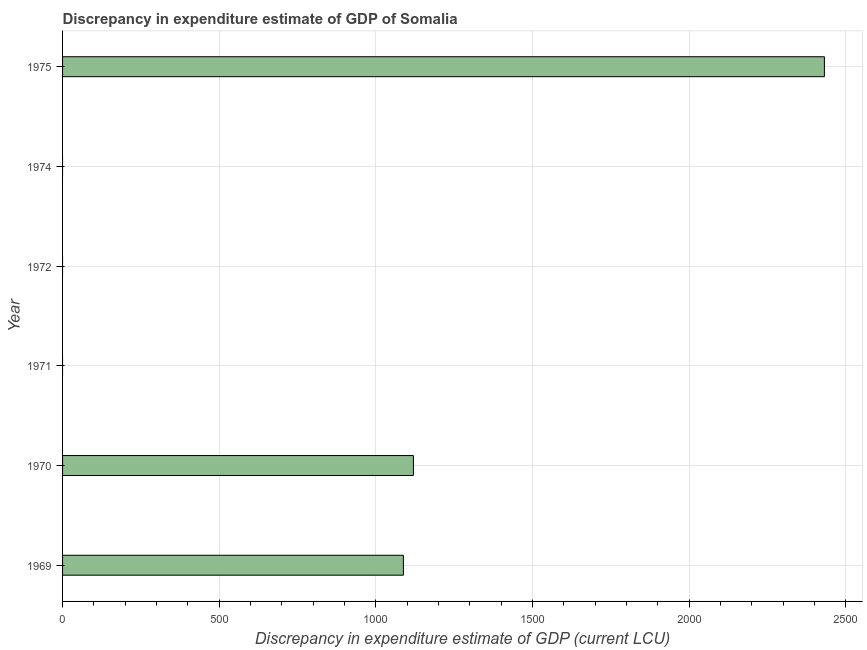What is the title of the graph?
Offer a terse response. Discrepancy in expenditure estimate of GDP of Somalia. What is the label or title of the X-axis?
Offer a terse response. Discrepancy in expenditure estimate of GDP (current LCU). What is the label or title of the Y-axis?
Offer a very short reply. Year. What is the discrepancy in expenditure estimate of gdp in 1971?
Your answer should be compact. 0. Across all years, what is the maximum discrepancy in expenditure estimate of gdp?
Your response must be concise. 2432. Across all years, what is the minimum discrepancy in expenditure estimate of gdp?
Offer a terse response. 0. In which year was the discrepancy in expenditure estimate of gdp maximum?
Make the answer very short. 1975. What is the sum of the discrepancy in expenditure estimate of gdp?
Your answer should be compact. 4640. What is the difference between the discrepancy in expenditure estimate of gdp in 1970 and 1975?
Provide a succinct answer. -1312. What is the average discrepancy in expenditure estimate of gdp per year?
Offer a terse response. 773. What is the median discrepancy in expenditure estimate of gdp?
Your answer should be very brief. 544. Is the discrepancy in expenditure estimate of gdp in 1970 less than that in 1975?
Provide a succinct answer. Yes. Is the difference between the discrepancy in expenditure estimate of gdp in 1970 and 1975 greater than the difference between any two years?
Make the answer very short. No. What is the difference between the highest and the second highest discrepancy in expenditure estimate of gdp?
Offer a terse response. 1312. What is the difference between the highest and the lowest discrepancy in expenditure estimate of gdp?
Give a very brief answer. 2432. In how many years, is the discrepancy in expenditure estimate of gdp greater than the average discrepancy in expenditure estimate of gdp taken over all years?
Offer a very short reply. 3. How many years are there in the graph?
Your answer should be very brief. 6. What is the difference between two consecutive major ticks on the X-axis?
Provide a short and direct response. 500. What is the Discrepancy in expenditure estimate of GDP (current LCU) in 1969?
Keep it short and to the point. 1088. What is the Discrepancy in expenditure estimate of GDP (current LCU) in 1970?
Make the answer very short. 1120. What is the Discrepancy in expenditure estimate of GDP (current LCU) of 1972?
Your answer should be very brief. 0. What is the Discrepancy in expenditure estimate of GDP (current LCU) in 1975?
Make the answer very short. 2432. What is the difference between the Discrepancy in expenditure estimate of GDP (current LCU) in 1969 and 1970?
Give a very brief answer. -32. What is the difference between the Discrepancy in expenditure estimate of GDP (current LCU) in 1969 and 1975?
Offer a terse response. -1344. What is the difference between the Discrepancy in expenditure estimate of GDP (current LCU) in 1970 and 1975?
Provide a succinct answer. -1312. What is the ratio of the Discrepancy in expenditure estimate of GDP (current LCU) in 1969 to that in 1975?
Provide a short and direct response. 0.45. What is the ratio of the Discrepancy in expenditure estimate of GDP (current LCU) in 1970 to that in 1975?
Your answer should be very brief. 0.46. 